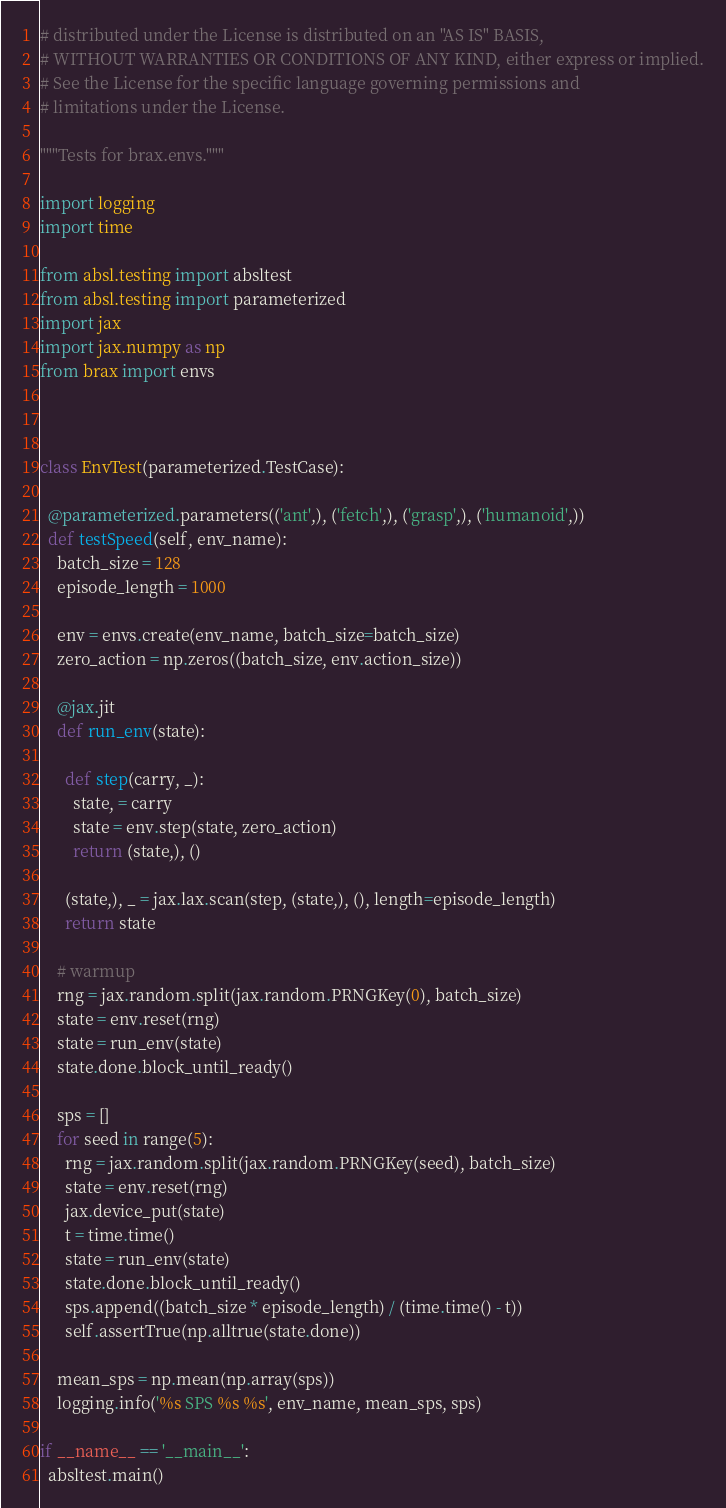Convert code to text. <code><loc_0><loc_0><loc_500><loc_500><_Python_># distributed under the License is distributed on an "AS IS" BASIS,
# WITHOUT WARRANTIES OR CONDITIONS OF ANY KIND, either express or implied.
# See the License for the specific language governing permissions and
# limitations under the License.

"""Tests for brax.envs."""

import logging
import time

from absl.testing import absltest
from absl.testing import parameterized
import jax
import jax.numpy as np
from brax import envs



class EnvTest(parameterized.TestCase):

  @parameterized.parameters(('ant',), ('fetch',), ('grasp',), ('humanoid',))
  def testSpeed(self, env_name):
    batch_size = 128
    episode_length = 1000

    env = envs.create(env_name, batch_size=batch_size)
    zero_action = np.zeros((batch_size, env.action_size))

    @jax.jit
    def run_env(state):

      def step(carry, _):
        state, = carry
        state = env.step(state, zero_action)
        return (state,), ()

      (state,), _ = jax.lax.scan(step, (state,), (), length=episode_length)
      return state

    # warmup
    rng = jax.random.split(jax.random.PRNGKey(0), batch_size)
    state = env.reset(rng)
    state = run_env(state)
    state.done.block_until_ready()

    sps = []
    for seed in range(5):
      rng = jax.random.split(jax.random.PRNGKey(seed), batch_size)
      state = env.reset(rng)
      jax.device_put(state)
      t = time.time()
      state = run_env(state)
      state.done.block_until_ready()
      sps.append((batch_size * episode_length) / (time.time() - t))
      self.assertTrue(np.alltrue(state.done))

    mean_sps = np.mean(np.array(sps))
    logging.info('%s SPS %s %s', env_name, mean_sps, sps)

if __name__ == '__main__':
  absltest.main()
</code> 